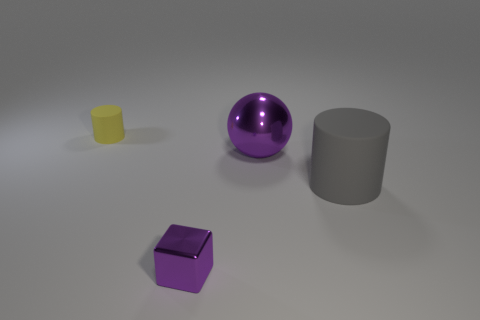What can you infer about the size of the objects? Without a reference point for scale, it is challenging to infer the exact size of the objects. However, based on common associations with shapes like these, they may be assumed to have a small to moderate size, such as models that could fit comfortably on a desk or table. 